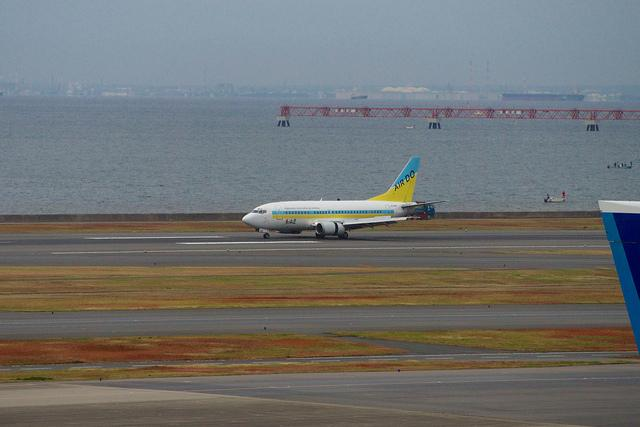The colors of this vehicle resemble which flag? Please explain your reasoning. argentina. Argentina's country colors are light blue, white and yellow. 